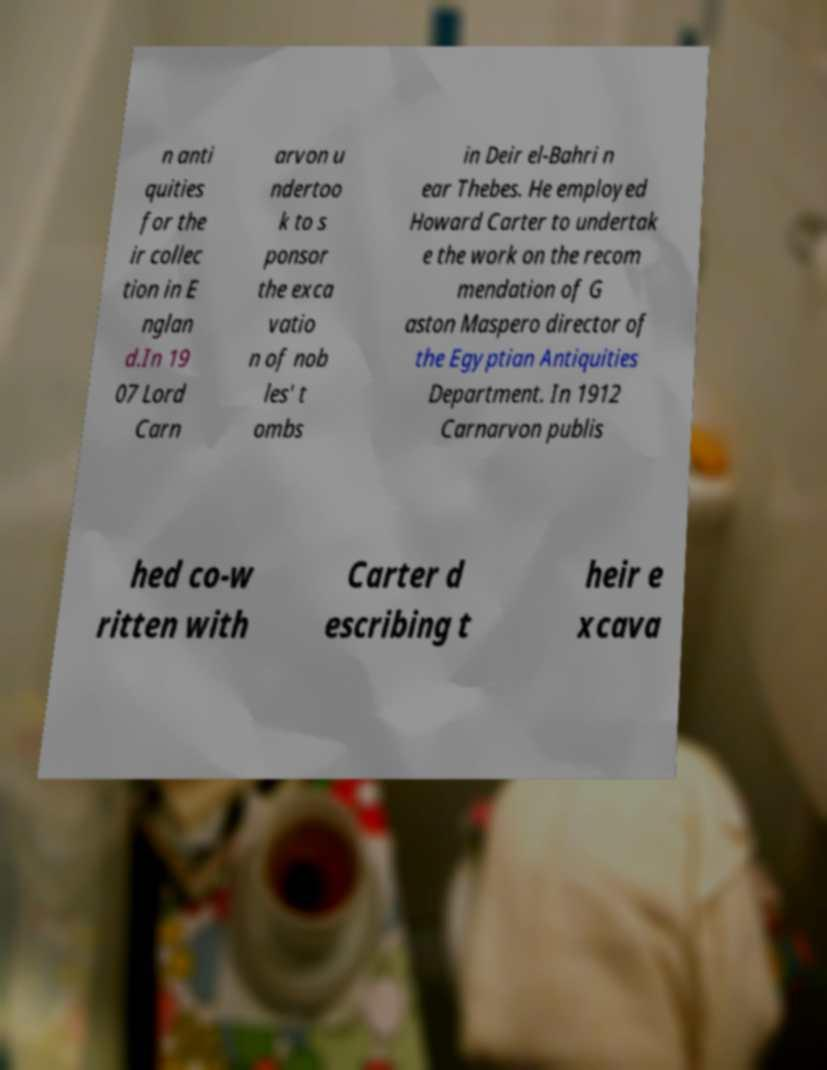There's text embedded in this image that I need extracted. Can you transcribe it verbatim? n anti quities for the ir collec tion in E nglan d.In 19 07 Lord Carn arvon u ndertoo k to s ponsor the exca vatio n of nob les' t ombs in Deir el-Bahri n ear Thebes. He employed Howard Carter to undertak e the work on the recom mendation of G aston Maspero director of the Egyptian Antiquities Department. In 1912 Carnarvon publis hed co-w ritten with Carter d escribing t heir e xcava 